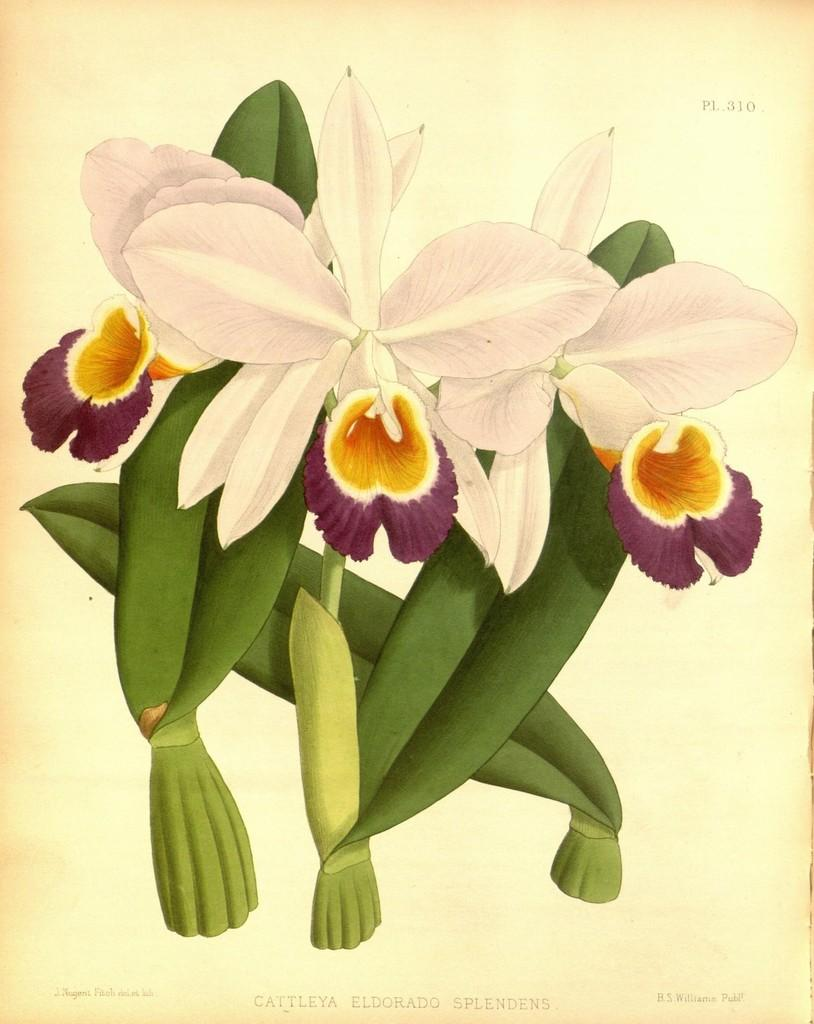What is the main subject of the image? The main subject of the image is a flower painting. What type of credit card is being used to pay for the flower painting in the image? There is no credit card or payment activity depicted in the image; it only features a flower painting. 